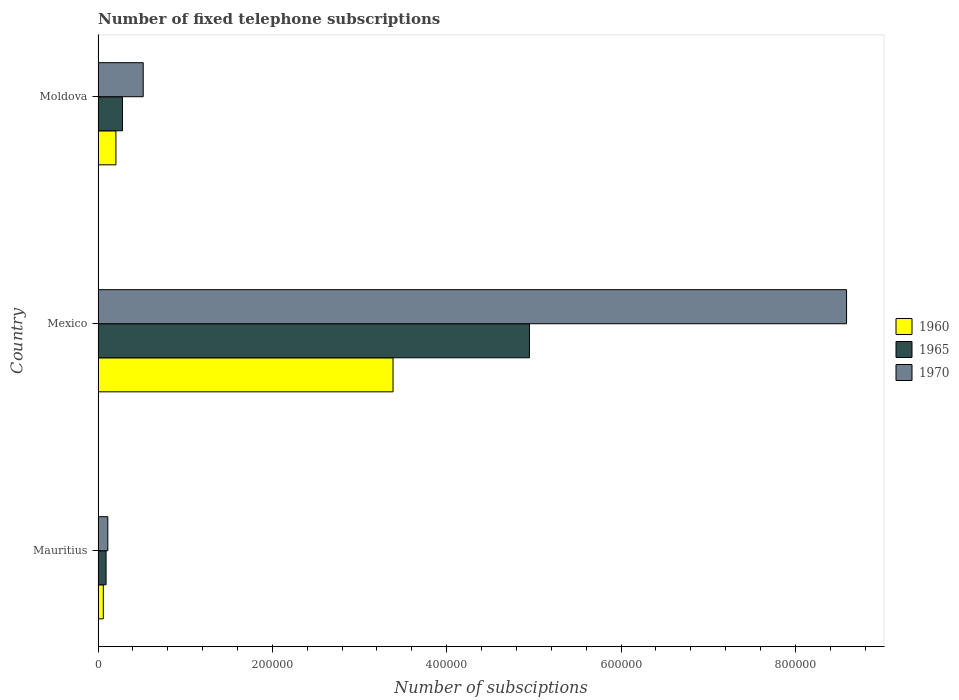How many different coloured bars are there?
Keep it short and to the point. 3. Are the number of bars per tick equal to the number of legend labels?
Your answer should be very brief. Yes. Are the number of bars on each tick of the Y-axis equal?
Your answer should be very brief. Yes. How many bars are there on the 2nd tick from the top?
Provide a short and direct response. 3. How many bars are there on the 1st tick from the bottom?
Keep it short and to the point. 3. What is the label of the 3rd group of bars from the top?
Your response must be concise. Mauritius. What is the number of fixed telephone subscriptions in 1970 in Mauritius?
Your answer should be very brief. 1.12e+04. Across all countries, what is the maximum number of fixed telephone subscriptions in 1960?
Your response must be concise. 3.38e+05. Across all countries, what is the minimum number of fixed telephone subscriptions in 1960?
Provide a succinct answer. 6047. In which country was the number of fixed telephone subscriptions in 1965 maximum?
Your answer should be very brief. Mexico. In which country was the number of fixed telephone subscriptions in 1970 minimum?
Your answer should be compact. Mauritius. What is the total number of fixed telephone subscriptions in 1965 in the graph?
Your response must be concise. 5.32e+05. What is the difference between the number of fixed telephone subscriptions in 1965 in Mauritius and that in Moldova?
Make the answer very short. -1.88e+04. What is the difference between the number of fixed telephone subscriptions in 1960 in Moldova and the number of fixed telephone subscriptions in 1965 in Mexico?
Offer a terse response. -4.74e+05. What is the average number of fixed telephone subscriptions in 1960 per country?
Your answer should be very brief. 1.22e+05. What is the difference between the number of fixed telephone subscriptions in 1960 and number of fixed telephone subscriptions in 1970 in Mauritius?
Make the answer very short. -5164. In how many countries, is the number of fixed telephone subscriptions in 1970 greater than 400000 ?
Your answer should be very brief. 1. What is the ratio of the number of fixed telephone subscriptions in 1965 in Mauritius to that in Moldova?
Offer a very short reply. 0.33. What is the difference between the highest and the second highest number of fixed telephone subscriptions in 1970?
Keep it short and to the point. 8.07e+05. What is the difference between the highest and the lowest number of fixed telephone subscriptions in 1960?
Ensure brevity in your answer.  3.32e+05. Is the sum of the number of fixed telephone subscriptions in 1960 in Mauritius and Moldova greater than the maximum number of fixed telephone subscriptions in 1970 across all countries?
Keep it short and to the point. No. What does the 2nd bar from the bottom in Mauritius represents?
Offer a terse response. 1965. How many bars are there?
Give a very brief answer. 9. Are all the bars in the graph horizontal?
Make the answer very short. Yes. How many countries are there in the graph?
Your response must be concise. 3. Does the graph contain grids?
Your response must be concise. No. Where does the legend appear in the graph?
Your response must be concise. Center right. How many legend labels are there?
Offer a terse response. 3. How are the legend labels stacked?
Provide a succinct answer. Vertical. What is the title of the graph?
Offer a very short reply. Number of fixed telephone subscriptions. Does "1964" appear as one of the legend labels in the graph?
Keep it short and to the point. No. What is the label or title of the X-axis?
Your answer should be very brief. Number of subsciptions. What is the Number of subsciptions in 1960 in Mauritius?
Offer a very short reply. 6047. What is the Number of subsciptions in 1965 in Mauritius?
Give a very brief answer. 9200. What is the Number of subsciptions in 1970 in Mauritius?
Provide a short and direct response. 1.12e+04. What is the Number of subsciptions of 1960 in Mexico?
Your answer should be compact. 3.38e+05. What is the Number of subsciptions in 1965 in Mexico?
Ensure brevity in your answer.  4.95e+05. What is the Number of subsciptions of 1970 in Mexico?
Provide a short and direct response. 8.59e+05. What is the Number of subsciptions in 1960 in Moldova?
Offer a very short reply. 2.05e+04. What is the Number of subsciptions of 1965 in Moldova?
Keep it short and to the point. 2.80e+04. What is the Number of subsciptions in 1970 in Moldova?
Provide a succinct answer. 5.18e+04. Across all countries, what is the maximum Number of subsciptions in 1960?
Your response must be concise. 3.38e+05. Across all countries, what is the maximum Number of subsciptions of 1965?
Your answer should be compact. 4.95e+05. Across all countries, what is the maximum Number of subsciptions in 1970?
Your answer should be very brief. 8.59e+05. Across all countries, what is the minimum Number of subsciptions of 1960?
Provide a short and direct response. 6047. Across all countries, what is the minimum Number of subsciptions of 1965?
Make the answer very short. 9200. Across all countries, what is the minimum Number of subsciptions in 1970?
Your response must be concise. 1.12e+04. What is the total Number of subsciptions of 1960 in the graph?
Offer a terse response. 3.65e+05. What is the total Number of subsciptions in 1965 in the graph?
Offer a very short reply. 5.32e+05. What is the total Number of subsciptions in 1970 in the graph?
Provide a succinct answer. 9.22e+05. What is the difference between the Number of subsciptions in 1960 in Mauritius and that in Mexico?
Ensure brevity in your answer.  -3.32e+05. What is the difference between the Number of subsciptions in 1965 in Mauritius and that in Mexico?
Offer a very short reply. -4.86e+05. What is the difference between the Number of subsciptions of 1970 in Mauritius and that in Mexico?
Your answer should be compact. -8.48e+05. What is the difference between the Number of subsciptions in 1960 in Mauritius and that in Moldova?
Your response must be concise. -1.45e+04. What is the difference between the Number of subsciptions in 1965 in Mauritius and that in Moldova?
Your answer should be very brief. -1.88e+04. What is the difference between the Number of subsciptions of 1970 in Mauritius and that in Moldova?
Ensure brevity in your answer.  -4.06e+04. What is the difference between the Number of subsciptions in 1960 in Mexico and that in Moldova?
Offer a terse response. 3.18e+05. What is the difference between the Number of subsciptions in 1965 in Mexico and that in Moldova?
Keep it short and to the point. 4.67e+05. What is the difference between the Number of subsciptions of 1970 in Mexico and that in Moldova?
Give a very brief answer. 8.07e+05. What is the difference between the Number of subsciptions in 1960 in Mauritius and the Number of subsciptions in 1965 in Mexico?
Give a very brief answer. -4.89e+05. What is the difference between the Number of subsciptions of 1960 in Mauritius and the Number of subsciptions of 1970 in Mexico?
Keep it short and to the point. -8.53e+05. What is the difference between the Number of subsciptions of 1965 in Mauritius and the Number of subsciptions of 1970 in Mexico?
Your answer should be very brief. -8.50e+05. What is the difference between the Number of subsciptions of 1960 in Mauritius and the Number of subsciptions of 1965 in Moldova?
Ensure brevity in your answer.  -2.20e+04. What is the difference between the Number of subsciptions in 1960 in Mauritius and the Number of subsciptions in 1970 in Moldova?
Ensure brevity in your answer.  -4.58e+04. What is the difference between the Number of subsciptions of 1965 in Mauritius and the Number of subsciptions of 1970 in Moldova?
Offer a very short reply. -4.26e+04. What is the difference between the Number of subsciptions of 1960 in Mexico and the Number of subsciptions of 1965 in Moldova?
Your answer should be very brief. 3.10e+05. What is the difference between the Number of subsciptions of 1960 in Mexico and the Number of subsciptions of 1970 in Moldova?
Your response must be concise. 2.87e+05. What is the difference between the Number of subsciptions of 1965 in Mexico and the Number of subsciptions of 1970 in Moldova?
Ensure brevity in your answer.  4.43e+05. What is the average Number of subsciptions in 1960 per country?
Ensure brevity in your answer.  1.22e+05. What is the average Number of subsciptions in 1965 per country?
Your answer should be compact. 1.77e+05. What is the average Number of subsciptions of 1970 per country?
Keep it short and to the point. 3.07e+05. What is the difference between the Number of subsciptions in 1960 and Number of subsciptions in 1965 in Mauritius?
Ensure brevity in your answer.  -3153. What is the difference between the Number of subsciptions of 1960 and Number of subsciptions of 1970 in Mauritius?
Your answer should be very brief. -5164. What is the difference between the Number of subsciptions in 1965 and Number of subsciptions in 1970 in Mauritius?
Your response must be concise. -2011. What is the difference between the Number of subsciptions of 1960 and Number of subsciptions of 1965 in Mexico?
Ensure brevity in your answer.  -1.56e+05. What is the difference between the Number of subsciptions of 1960 and Number of subsciptions of 1970 in Mexico?
Provide a short and direct response. -5.20e+05. What is the difference between the Number of subsciptions of 1965 and Number of subsciptions of 1970 in Mexico?
Offer a terse response. -3.64e+05. What is the difference between the Number of subsciptions of 1960 and Number of subsciptions of 1965 in Moldova?
Offer a terse response. -7500. What is the difference between the Number of subsciptions of 1960 and Number of subsciptions of 1970 in Moldova?
Your answer should be compact. -3.13e+04. What is the difference between the Number of subsciptions of 1965 and Number of subsciptions of 1970 in Moldova?
Offer a terse response. -2.38e+04. What is the ratio of the Number of subsciptions of 1960 in Mauritius to that in Mexico?
Offer a terse response. 0.02. What is the ratio of the Number of subsciptions in 1965 in Mauritius to that in Mexico?
Your response must be concise. 0.02. What is the ratio of the Number of subsciptions of 1970 in Mauritius to that in Mexico?
Give a very brief answer. 0.01. What is the ratio of the Number of subsciptions of 1960 in Mauritius to that in Moldova?
Give a very brief answer. 0.29. What is the ratio of the Number of subsciptions of 1965 in Mauritius to that in Moldova?
Make the answer very short. 0.33. What is the ratio of the Number of subsciptions in 1970 in Mauritius to that in Moldova?
Your answer should be compact. 0.22. What is the ratio of the Number of subsciptions of 1960 in Mexico to that in Moldova?
Make the answer very short. 16.51. What is the ratio of the Number of subsciptions in 1965 in Mexico to that in Moldova?
Ensure brevity in your answer.  17.68. What is the ratio of the Number of subsciptions in 1970 in Mexico to that in Moldova?
Keep it short and to the point. 16.58. What is the difference between the highest and the second highest Number of subsciptions of 1960?
Ensure brevity in your answer.  3.18e+05. What is the difference between the highest and the second highest Number of subsciptions of 1965?
Provide a short and direct response. 4.67e+05. What is the difference between the highest and the second highest Number of subsciptions in 1970?
Your response must be concise. 8.07e+05. What is the difference between the highest and the lowest Number of subsciptions in 1960?
Your answer should be compact. 3.32e+05. What is the difference between the highest and the lowest Number of subsciptions in 1965?
Your answer should be compact. 4.86e+05. What is the difference between the highest and the lowest Number of subsciptions of 1970?
Ensure brevity in your answer.  8.48e+05. 